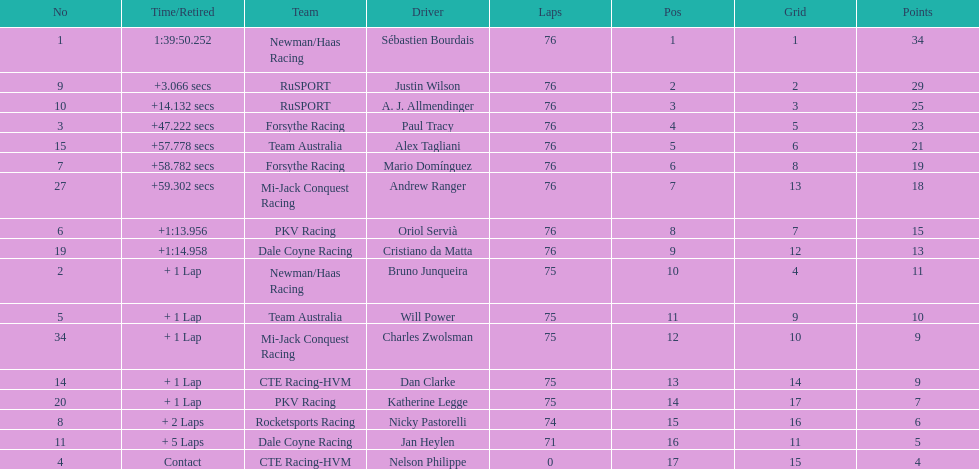How many drivers were competing for brazil? 2. 